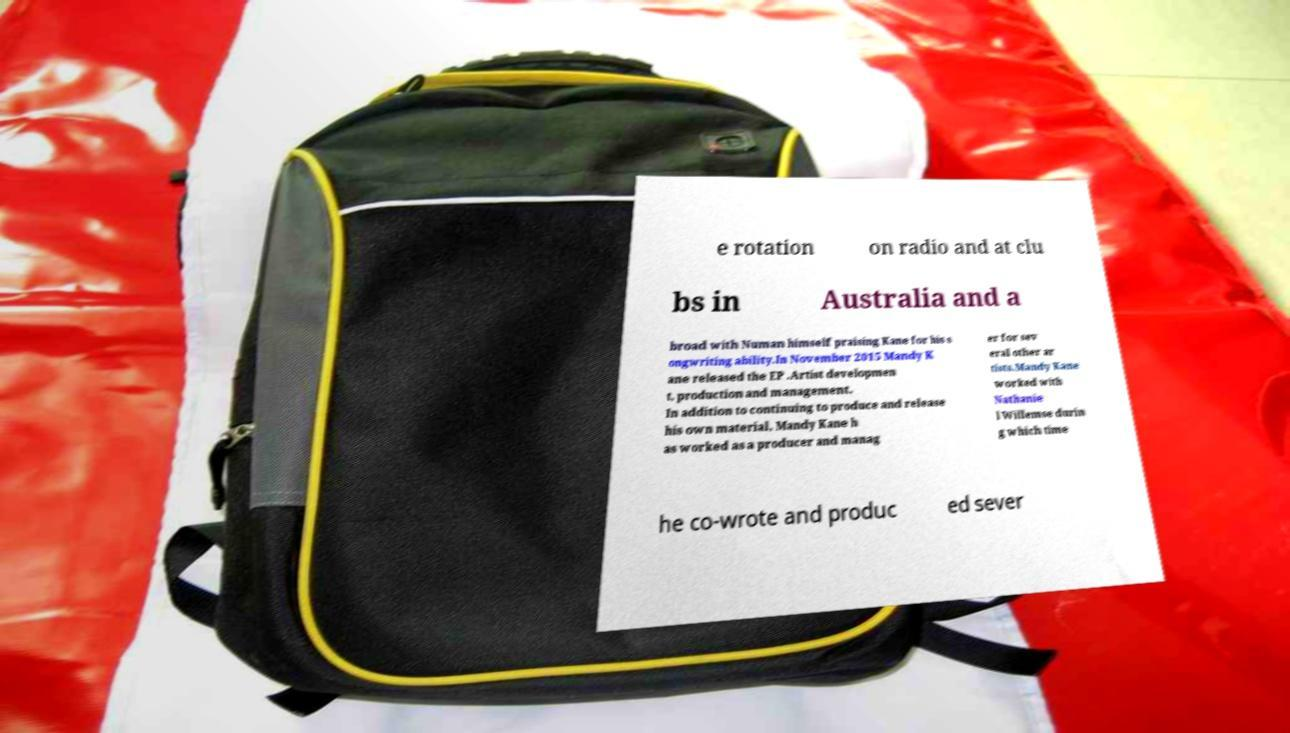For documentation purposes, I need the text within this image transcribed. Could you provide that? e rotation on radio and at clu bs in Australia and a broad with Numan himself praising Kane for his s ongwriting ability.In November 2015 Mandy K ane released the EP .Artist developmen t, production and management. In addition to continuing to produce and release his own material, Mandy Kane h as worked as a producer and manag er for sev eral other ar tists.Mandy Kane worked with Nathanie l Willemse durin g which time he co-wrote and produc ed sever 